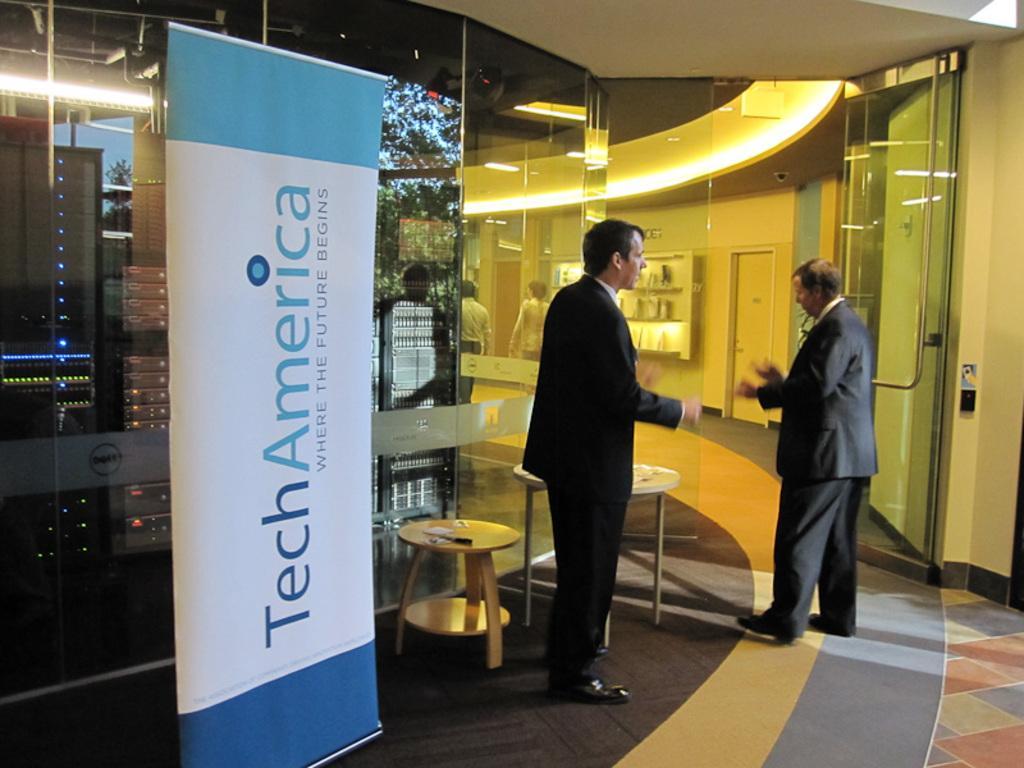How would you summarize this image in a sentence or two? In this image there are two persons standing inside a hall, on either side of the persons there is a glass wall and there is a banner on that banner there is some text, at the top there is ceiling and lights. 